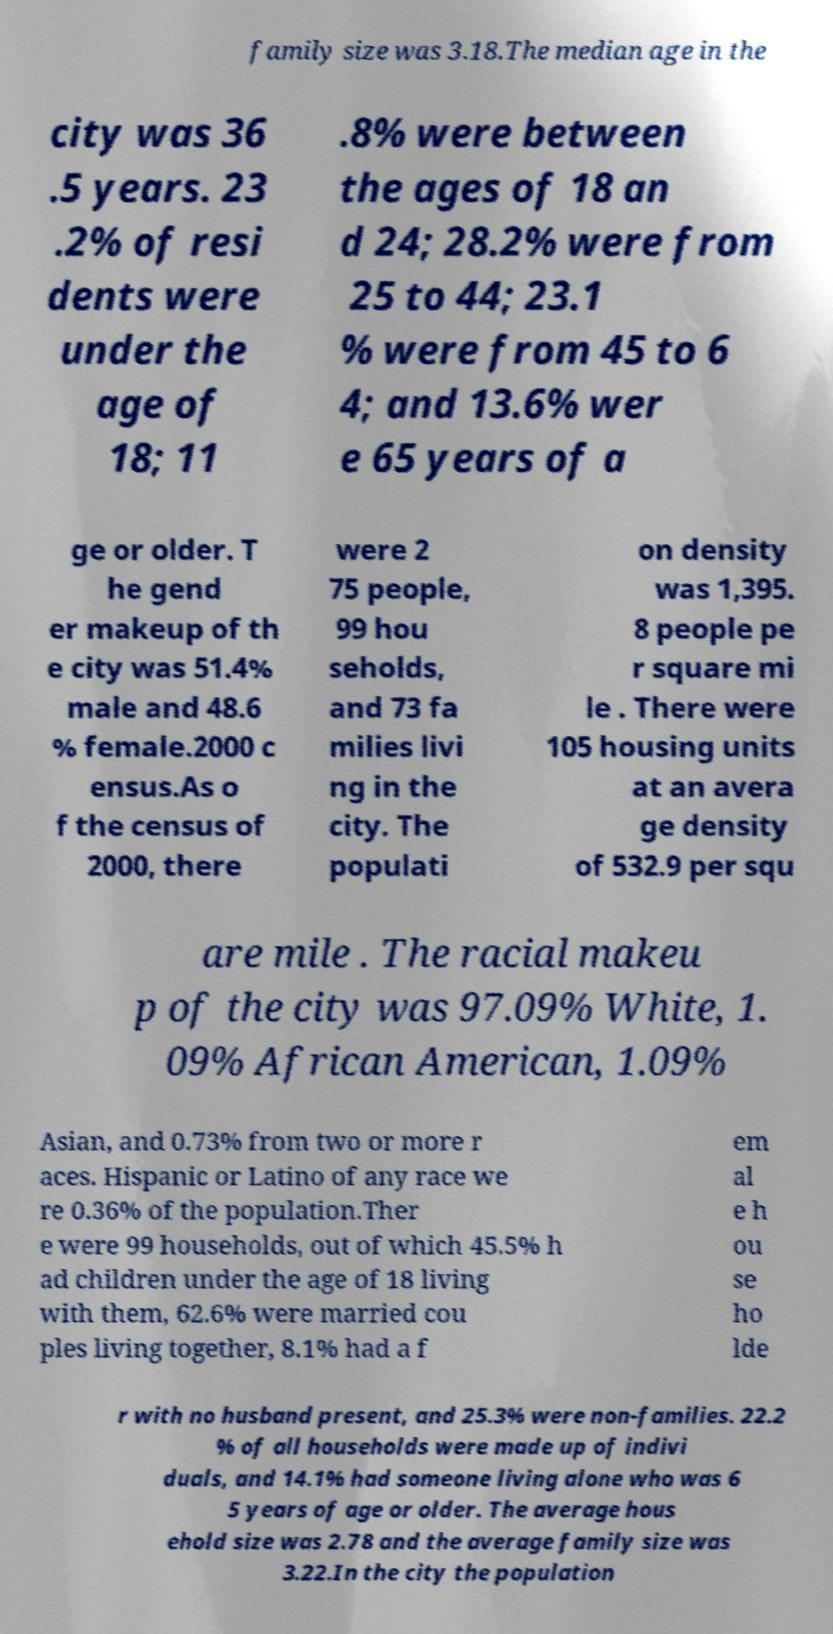For documentation purposes, I need the text within this image transcribed. Could you provide that? family size was 3.18.The median age in the city was 36 .5 years. 23 .2% of resi dents were under the age of 18; 11 .8% were between the ages of 18 an d 24; 28.2% were from 25 to 44; 23.1 % were from 45 to 6 4; and 13.6% wer e 65 years of a ge or older. T he gend er makeup of th e city was 51.4% male and 48.6 % female.2000 c ensus.As o f the census of 2000, there were 2 75 people, 99 hou seholds, and 73 fa milies livi ng in the city. The populati on density was 1,395. 8 people pe r square mi le . There were 105 housing units at an avera ge density of 532.9 per squ are mile . The racial makeu p of the city was 97.09% White, 1. 09% African American, 1.09% Asian, and 0.73% from two or more r aces. Hispanic or Latino of any race we re 0.36% of the population.Ther e were 99 households, out of which 45.5% h ad children under the age of 18 living with them, 62.6% were married cou ples living together, 8.1% had a f em al e h ou se ho lde r with no husband present, and 25.3% were non-families. 22.2 % of all households were made up of indivi duals, and 14.1% had someone living alone who was 6 5 years of age or older. The average hous ehold size was 2.78 and the average family size was 3.22.In the city the population 